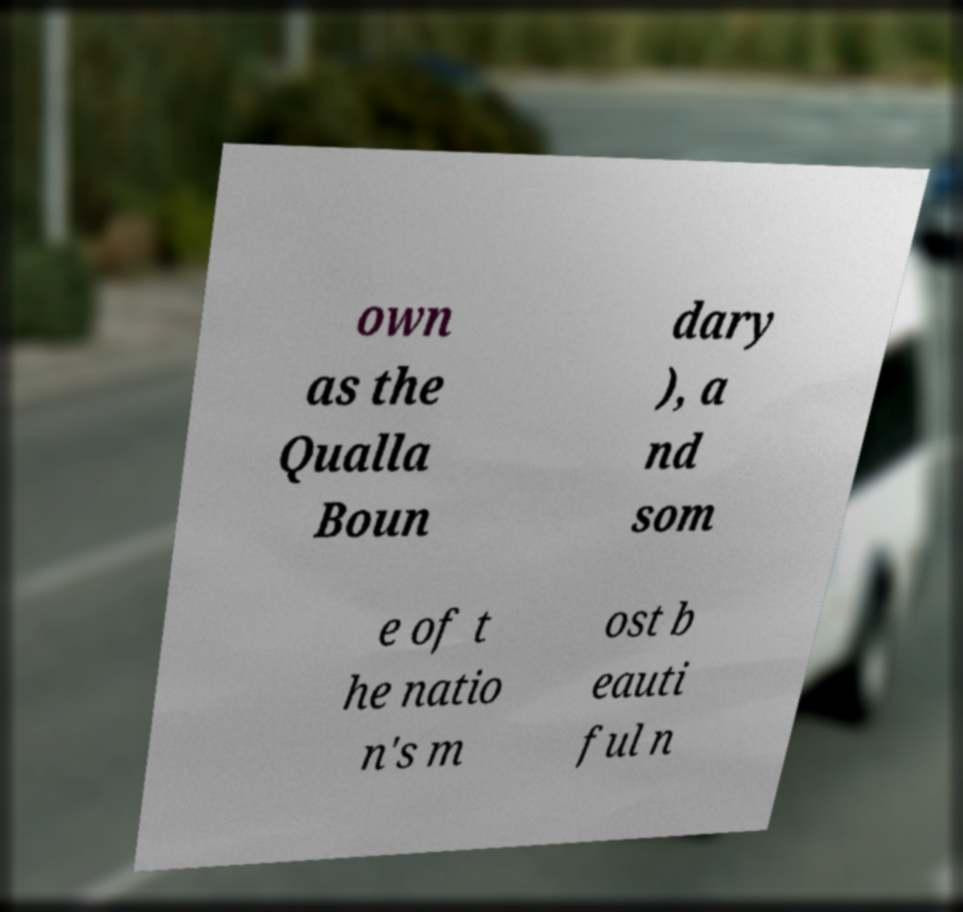Could you extract and type out the text from this image? own as the Qualla Boun dary ), a nd som e of t he natio n's m ost b eauti ful n 